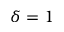Convert formula to latex. <formula><loc_0><loc_0><loc_500><loc_500>\delta = 1</formula> 